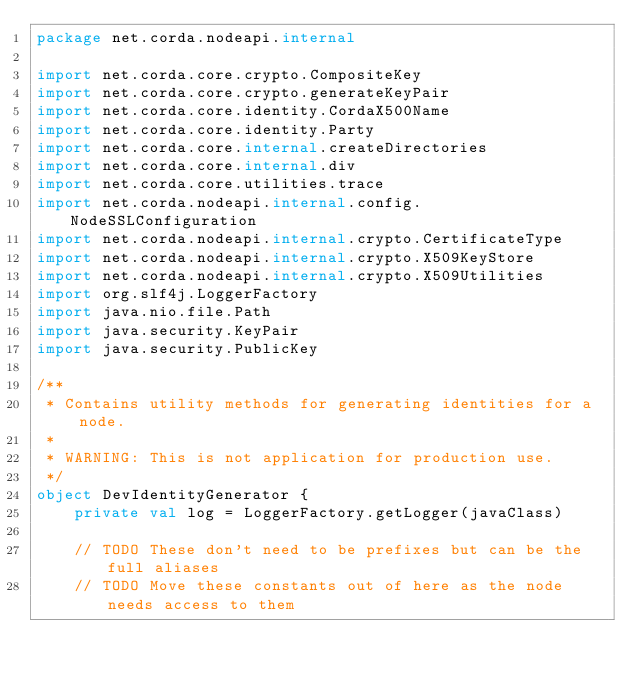Convert code to text. <code><loc_0><loc_0><loc_500><loc_500><_Kotlin_>package net.corda.nodeapi.internal

import net.corda.core.crypto.CompositeKey
import net.corda.core.crypto.generateKeyPair
import net.corda.core.identity.CordaX500Name
import net.corda.core.identity.Party
import net.corda.core.internal.createDirectories
import net.corda.core.internal.div
import net.corda.core.utilities.trace
import net.corda.nodeapi.internal.config.NodeSSLConfiguration
import net.corda.nodeapi.internal.crypto.CertificateType
import net.corda.nodeapi.internal.crypto.X509KeyStore
import net.corda.nodeapi.internal.crypto.X509Utilities
import org.slf4j.LoggerFactory
import java.nio.file.Path
import java.security.KeyPair
import java.security.PublicKey

/**
 * Contains utility methods for generating identities for a node.
 *
 * WARNING: This is not application for production use.
 */
object DevIdentityGenerator {
    private val log = LoggerFactory.getLogger(javaClass)

    // TODO These don't need to be prefixes but can be the full aliases
    // TODO Move these constants out of here as the node needs access to them</code> 